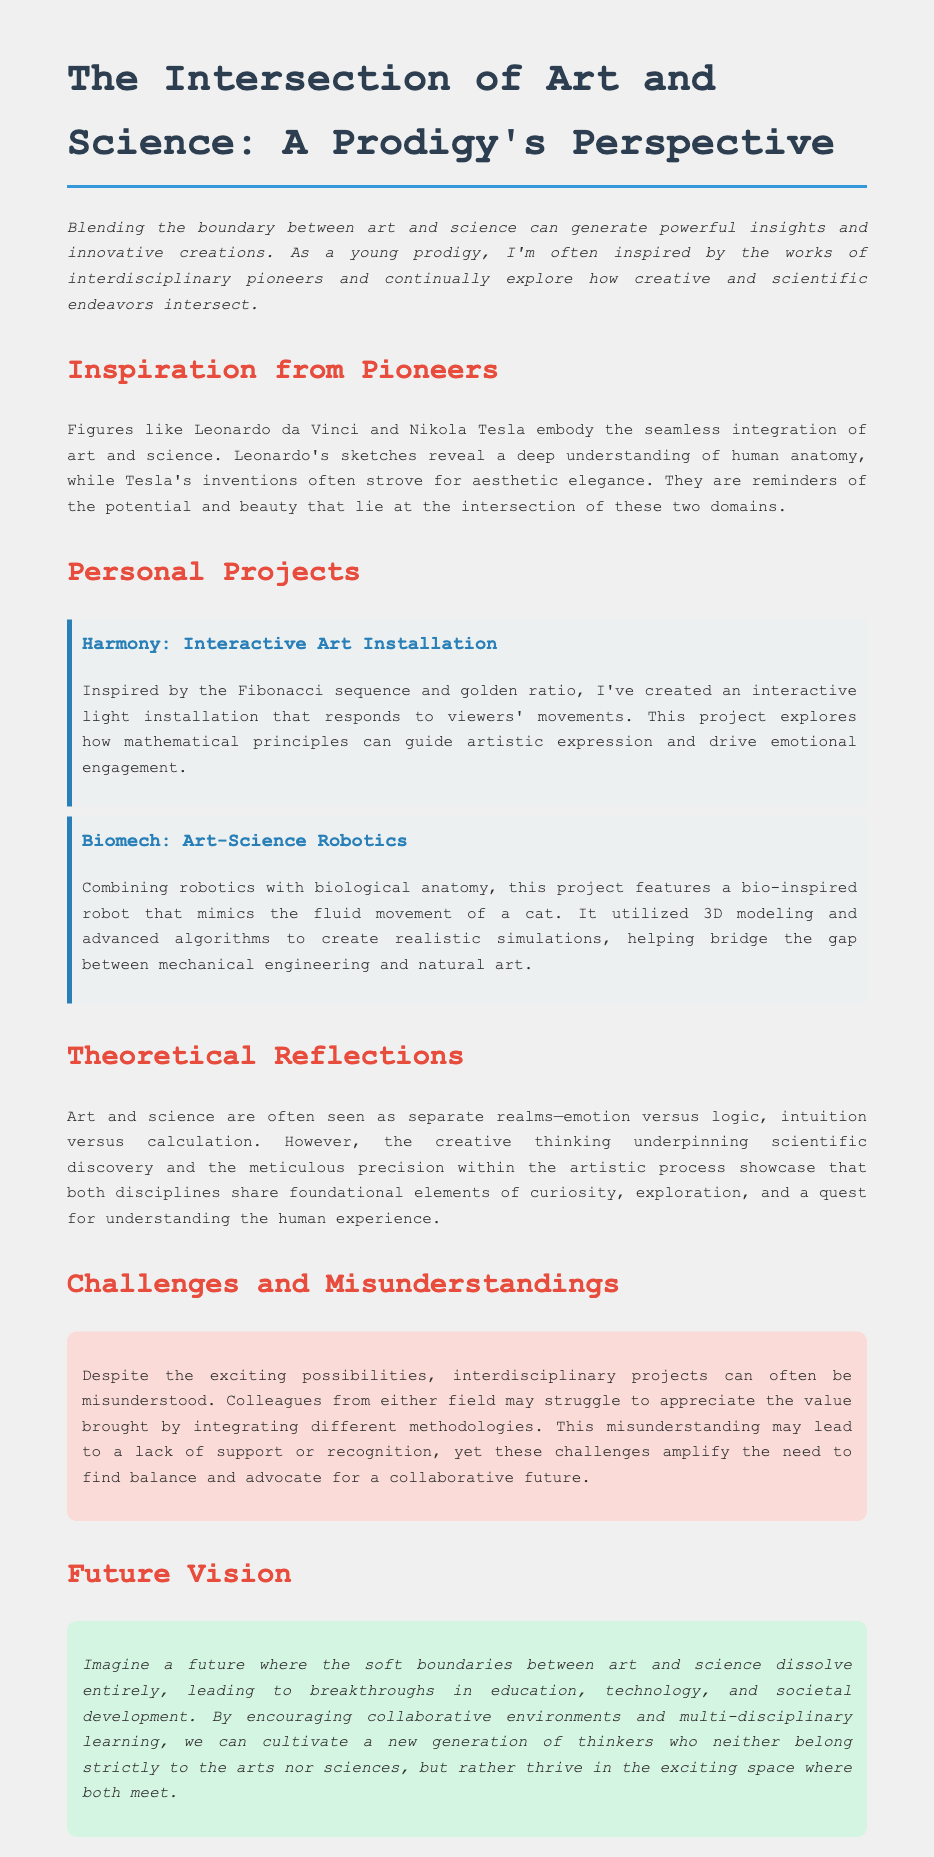What is the title of the document? The title is found in the header of the document, indicating the main subject being discussed.
Answer: The Intersection of Art and Science: A Prodigy's Perspective Who are two historical figures mentioned as inspirations? The document lists names of influential figures who exemplify the blend of art and science.
Answer: Leonardo da Vinci and Nikola Tesla What is the first personal project described? The document provides details about various personal projects, with the first one listed in the section about personal projects.
Answer: Harmony: Interactive Art Installation What mathematical principle inspired the interactive light installation? The explanation of the light installation includes its foundation on a specific mathematical concept that guided its creation.
Answer: Fibonacci sequence What challenge is mentioned regarding interdisciplinary projects? The document outlines difficulties faced in interdisciplinary work, highlighting the nature of these misunderstandings.
Answer: Misunderstanding What vision for the future is described in the document? The future vision discusses the potential evolution and merging of disciplines in future educational and societal contexts.
Answer: Collaborative environments 